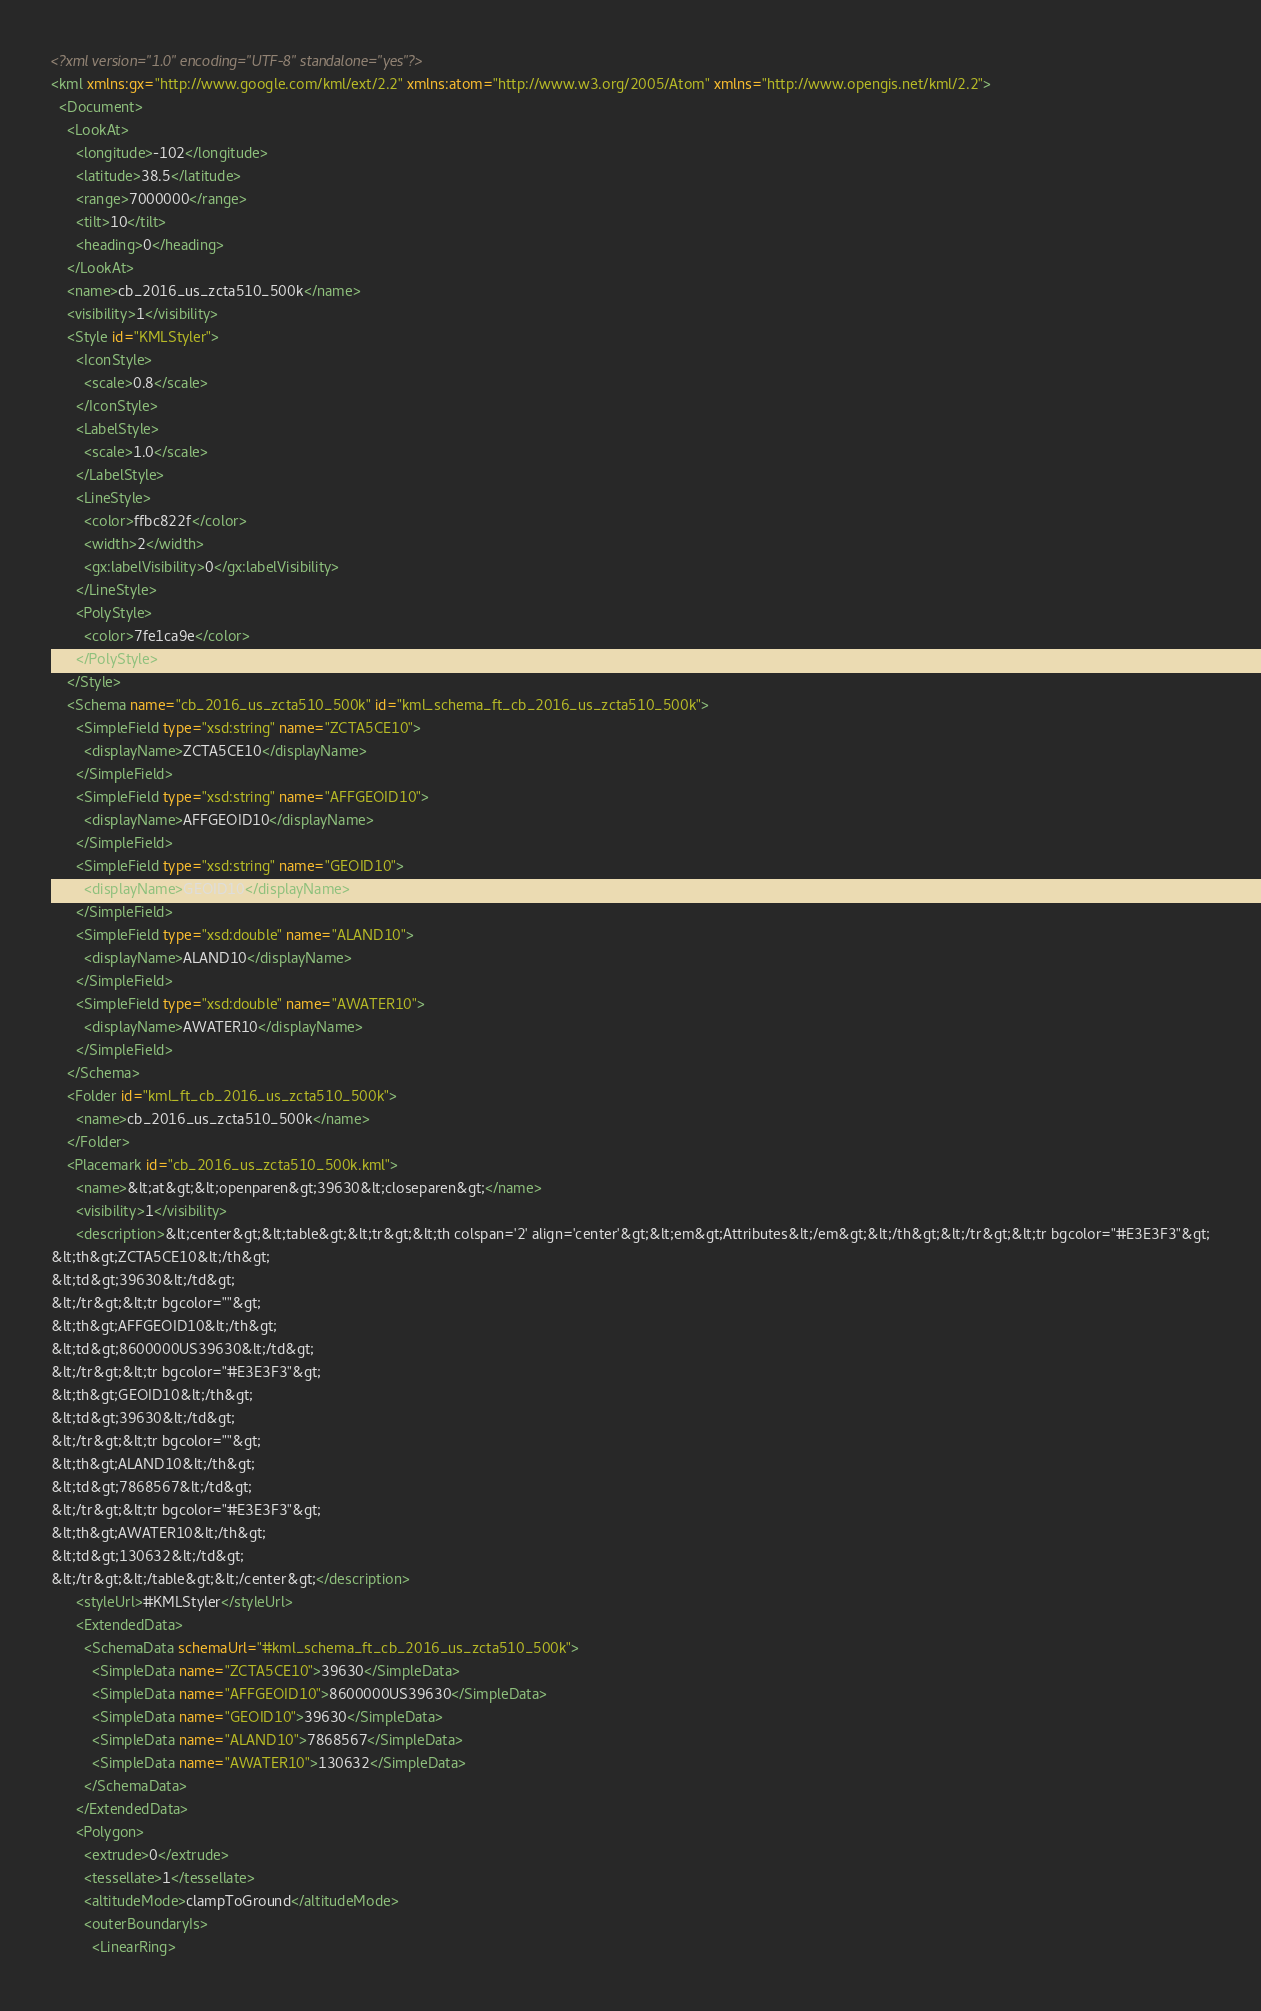<code> <loc_0><loc_0><loc_500><loc_500><_XML_><?xml version="1.0" encoding="UTF-8" standalone="yes"?>
<kml xmlns:gx="http://www.google.com/kml/ext/2.2" xmlns:atom="http://www.w3.org/2005/Atom" xmlns="http://www.opengis.net/kml/2.2">
  <Document>
    <LookAt>
      <longitude>-102</longitude>
      <latitude>38.5</latitude>
      <range>7000000</range>
      <tilt>10</tilt>
      <heading>0</heading>
    </LookAt>
    <name>cb_2016_us_zcta510_500k</name>
    <visibility>1</visibility>
    <Style id="KMLStyler">
      <IconStyle>
        <scale>0.8</scale>
      </IconStyle>
      <LabelStyle>
        <scale>1.0</scale>
      </LabelStyle>
      <LineStyle>
        <color>ffbc822f</color>
        <width>2</width>
        <gx:labelVisibility>0</gx:labelVisibility>
      </LineStyle>
      <PolyStyle>
        <color>7fe1ca9e</color>
      </PolyStyle>
    </Style>
    <Schema name="cb_2016_us_zcta510_500k" id="kml_schema_ft_cb_2016_us_zcta510_500k">
      <SimpleField type="xsd:string" name="ZCTA5CE10">
        <displayName>ZCTA5CE10</displayName>
      </SimpleField>
      <SimpleField type="xsd:string" name="AFFGEOID10">
        <displayName>AFFGEOID10</displayName>
      </SimpleField>
      <SimpleField type="xsd:string" name="GEOID10">
        <displayName>GEOID10</displayName>
      </SimpleField>
      <SimpleField type="xsd:double" name="ALAND10">
        <displayName>ALAND10</displayName>
      </SimpleField>
      <SimpleField type="xsd:double" name="AWATER10">
        <displayName>AWATER10</displayName>
      </SimpleField>
    </Schema>
    <Folder id="kml_ft_cb_2016_us_zcta510_500k">
      <name>cb_2016_us_zcta510_500k</name>
    </Folder>
    <Placemark id="cb_2016_us_zcta510_500k.kml">
      <name>&lt;at&gt;&lt;openparen&gt;39630&lt;closeparen&gt;</name>
      <visibility>1</visibility>
      <description>&lt;center&gt;&lt;table&gt;&lt;tr&gt;&lt;th colspan='2' align='center'&gt;&lt;em&gt;Attributes&lt;/em&gt;&lt;/th&gt;&lt;/tr&gt;&lt;tr bgcolor="#E3E3F3"&gt;
&lt;th&gt;ZCTA5CE10&lt;/th&gt;
&lt;td&gt;39630&lt;/td&gt;
&lt;/tr&gt;&lt;tr bgcolor=""&gt;
&lt;th&gt;AFFGEOID10&lt;/th&gt;
&lt;td&gt;8600000US39630&lt;/td&gt;
&lt;/tr&gt;&lt;tr bgcolor="#E3E3F3"&gt;
&lt;th&gt;GEOID10&lt;/th&gt;
&lt;td&gt;39630&lt;/td&gt;
&lt;/tr&gt;&lt;tr bgcolor=""&gt;
&lt;th&gt;ALAND10&lt;/th&gt;
&lt;td&gt;7868567&lt;/td&gt;
&lt;/tr&gt;&lt;tr bgcolor="#E3E3F3"&gt;
&lt;th&gt;AWATER10&lt;/th&gt;
&lt;td&gt;130632&lt;/td&gt;
&lt;/tr&gt;&lt;/table&gt;&lt;/center&gt;</description>
      <styleUrl>#KMLStyler</styleUrl>
      <ExtendedData>
        <SchemaData schemaUrl="#kml_schema_ft_cb_2016_us_zcta510_500k">
          <SimpleData name="ZCTA5CE10">39630</SimpleData>
          <SimpleData name="AFFGEOID10">8600000US39630</SimpleData>
          <SimpleData name="GEOID10">39630</SimpleData>
          <SimpleData name="ALAND10">7868567</SimpleData>
          <SimpleData name="AWATER10">130632</SimpleData>
        </SchemaData>
      </ExtendedData>
      <Polygon>
        <extrude>0</extrude>
        <tessellate>1</tessellate>
        <altitudeMode>clampToGround</altitudeMode>
        <outerBoundaryIs>
          <LinearRing></code> 